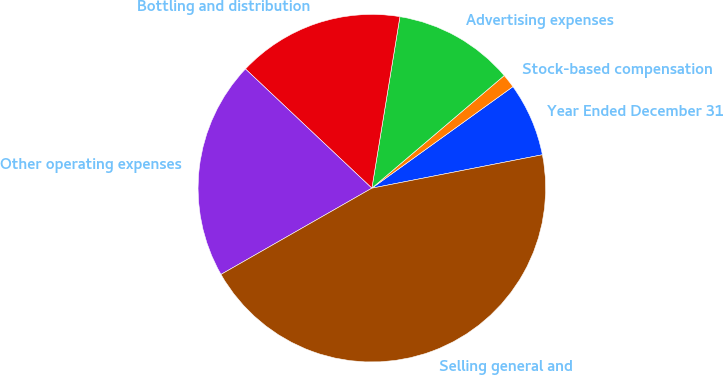Convert chart to OTSL. <chart><loc_0><loc_0><loc_500><loc_500><pie_chart><fcel>Year Ended December 31<fcel>Stock-based compensation<fcel>Advertising expenses<fcel>Bottling and distribution<fcel>Other operating expenses<fcel>Selling general and<nl><fcel>6.85%<fcel>1.29%<fcel>11.2%<fcel>15.55%<fcel>20.3%<fcel>44.82%<nl></chart> 